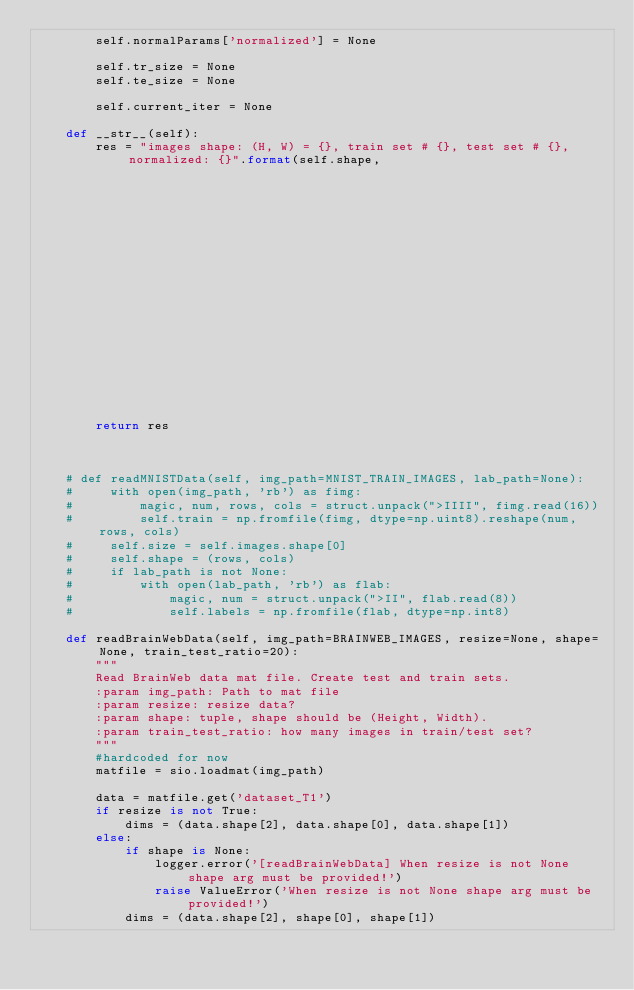Convert code to text. <code><loc_0><loc_0><loc_500><loc_500><_Python_>        self.normalParams['normalized'] = None

        self.tr_size = None
        self.te_size = None

        self.current_iter = None

    def __str__(self):
        res = "images shape: (H, W) = {}, train set # {}, test set # {}, normalized: {}".format(self.shape,
                                                                                                   self.tr_size,
                                                                                                   self.te_size,
                                                                                                   self.normalParams['normalized'])
        return res



    # def readMNISTData(self, img_path=MNIST_TRAIN_IMAGES, lab_path=None):
    #     with open(img_path, 'rb') as fimg:
    #         magic, num, rows, cols = struct.unpack(">IIII", fimg.read(16))
    #         self.train = np.fromfile(fimg, dtype=np.uint8).reshape(num, rows, cols)
    #     self.size = self.images.shape[0]
    #     self.shape = (rows, cols)
    #     if lab_path is not None:
    #         with open(lab_path, 'rb') as flab:
    #             magic, num = struct.unpack(">II", flab.read(8))
    #             self.labels = np.fromfile(flab, dtype=np.int8)

    def readBrainWebData(self, img_path=BRAINWEB_IMAGES, resize=None, shape=None, train_test_ratio=20):
        """
        Read BrainWeb data mat file. Create test and train sets.
        :param img_path: Path to mat file
        :param resize: resize data?
        :param shape: tuple, shape should be (Height, Width).
        :param train_test_ratio: how many images in train/test set?
        """
        #hardcoded for now
        matfile = sio.loadmat(img_path)

        data = matfile.get('dataset_T1')
        if resize is not True:
            dims = (data.shape[2], data.shape[0], data.shape[1])
        else:
            if shape is None:
                logger.error('[readBrainWebData] When resize is not None shape arg must be provided!')
                raise ValueError('When resize is not None shape arg must be provided!')
            dims = (data.shape[2], shape[0], shape[1])
</code> 